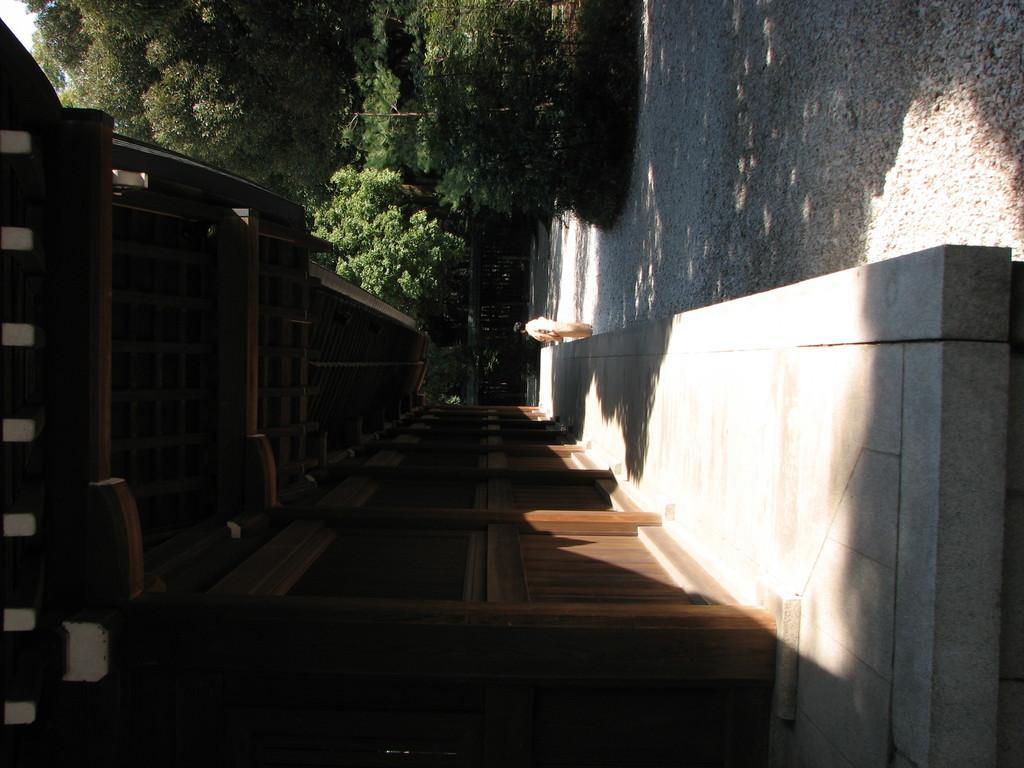Could you give a brief overview of what you see in this image? In this image I see the wooden wall over here and I see the platform over here and I see a person. In the background I see the trees and I see the shadow on the ground. 